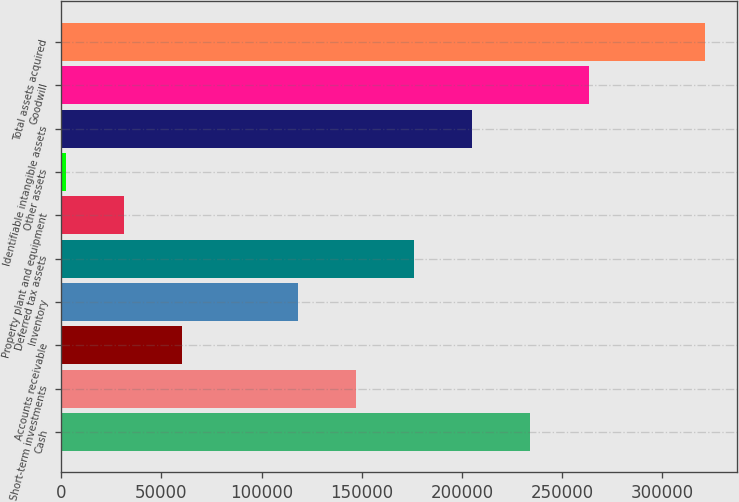Convert chart to OTSL. <chart><loc_0><loc_0><loc_500><loc_500><bar_chart><fcel>Cash<fcel>Short-term investments<fcel>Accounts receivable<fcel>Inventory<fcel>Deferred tax assets<fcel>Property plant and equipment<fcel>Other assets<fcel>Identifiable intangible assets<fcel>Goodwill<fcel>Total assets acquired<nl><fcel>234177<fcel>147162<fcel>60148.4<fcel>118158<fcel>176167<fcel>31143.7<fcel>2139<fcel>205172<fcel>263181<fcel>321191<nl></chart> 